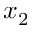Convert formula to latex. <formula><loc_0><loc_0><loc_500><loc_500>x _ { 2 }</formula> 